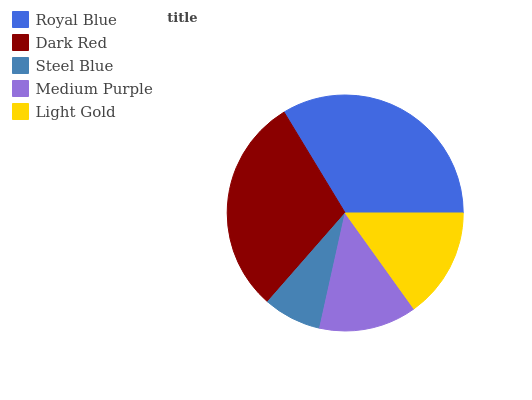Is Steel Blue the minimum?
Answer yes or no. Yes. Is Royal Blue the maximum?
Answer yes or no. Yes. Is Dark Red the minimum?
Answer yes or no. No. Is Dark Red the maximum?
Answer yes or no. No. Is Royal Blue greater than Dark Red?
Answer yes or no. Yes. Is Dark Red less than Royal Blue?
Answer yes or no. Yes. Is Dark Red greater than Royal Blue?
Answer yes or no. No. Is Royal Blue less than Dark Red?
Answer yes or no. No. Is Light Gold the high median?
Answer yes or no. Yes. Is Light Gold the low median?
Answer yes or no. Yes. Is Steel Blue the high median?
Answer yes or no. No. Is Medium Purple the low median?
Answer yes or no. No. 